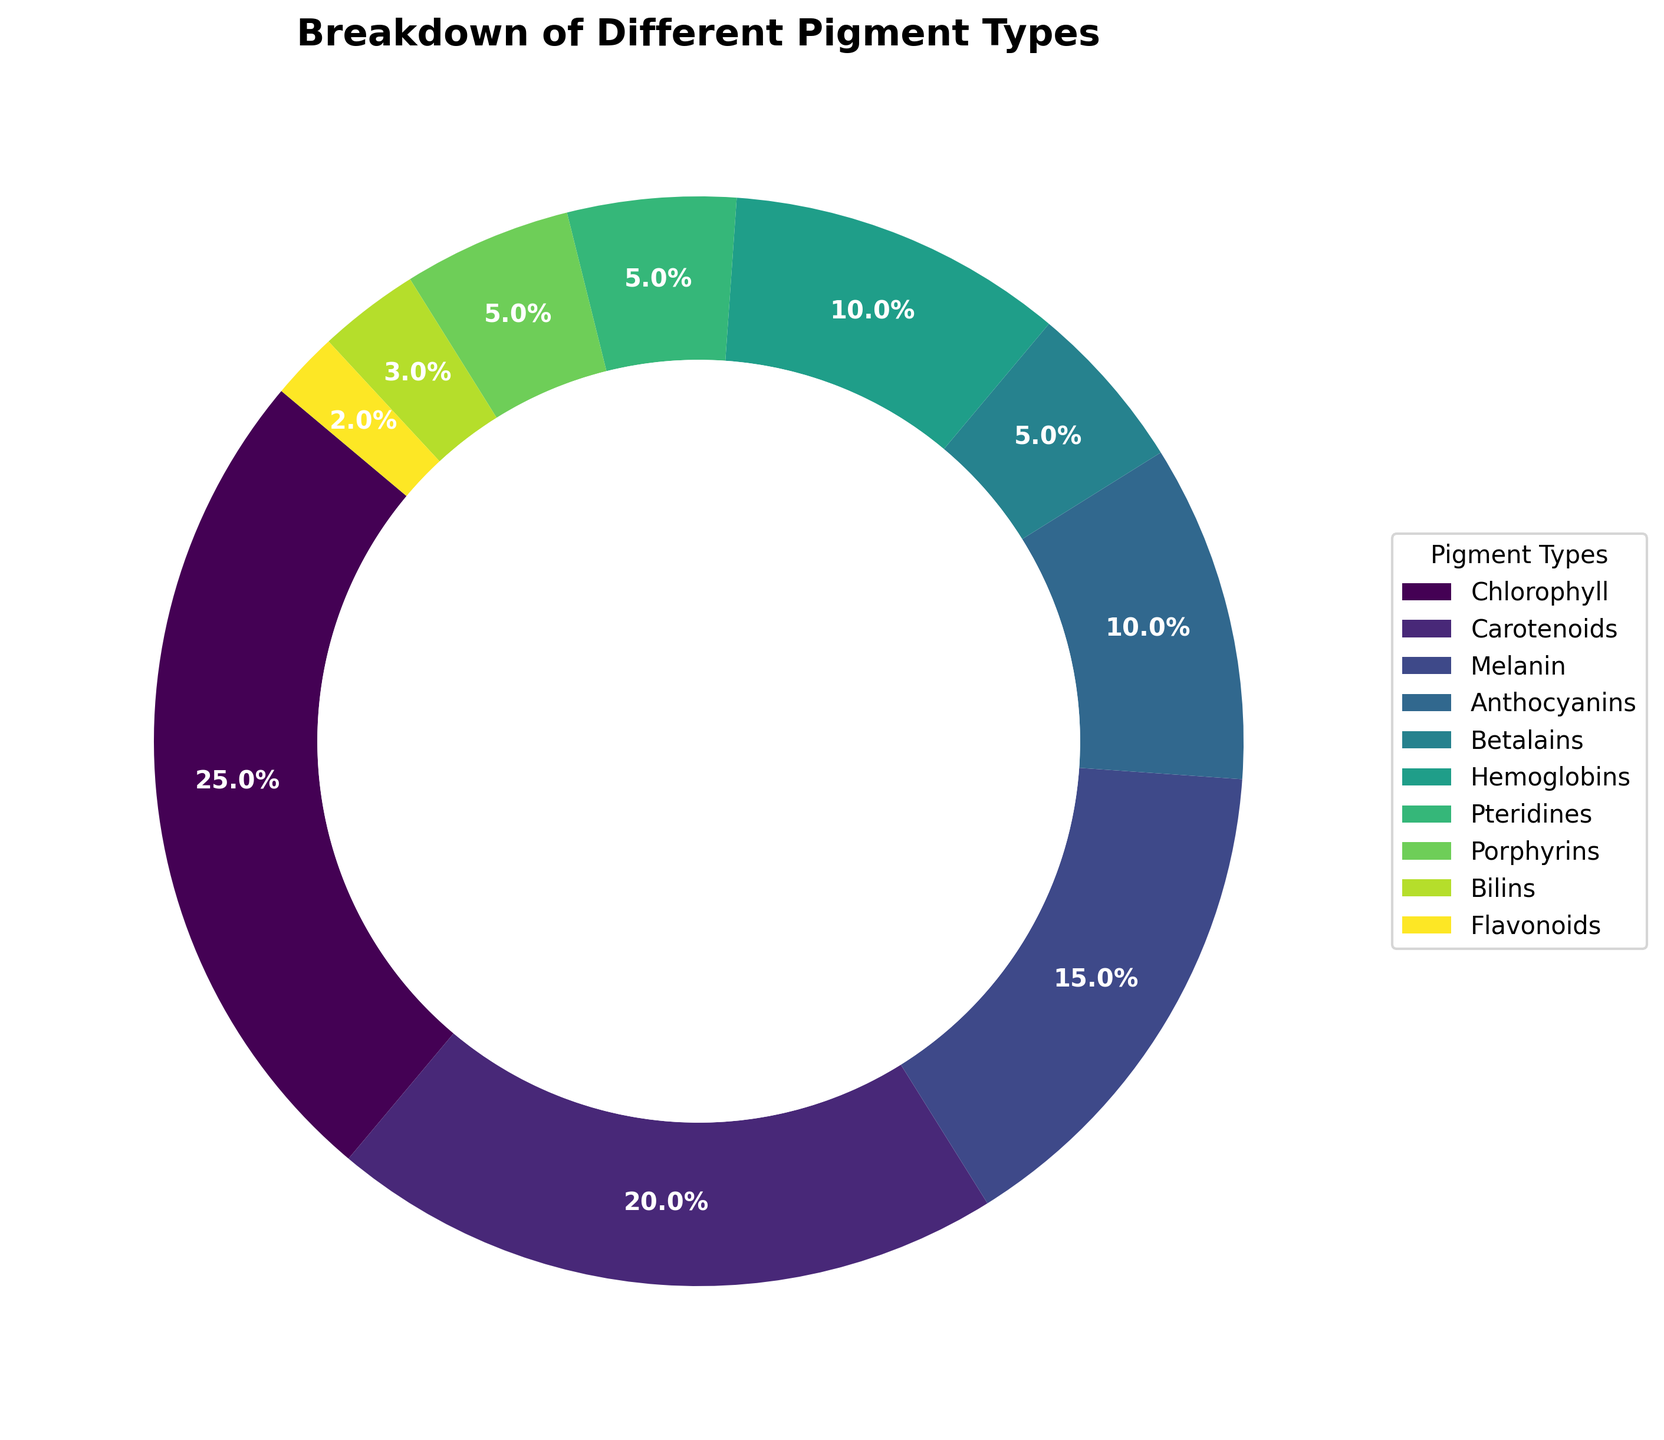Which pigment type is the most abundant in the figure? By referring to the figure, we can see that chlorophyll takes up the largest portion of the pie chart, which is 25%.
Answer: Chlorophyll How much more prevalent is chlorophyll compared to flavonoids? Chlorophyll is 25% while flavonoids are 2%. Calculate the difference: 25% - 2% = 23%.
Answer: 23% What percentage of the pie chart do carotenoids and anthocyanins together represent? Carotenoids make up 20% and anthocyanins 10%. Add these percentages together: 20% + 10% = 30%.
Answer: 30% Which pigment types have an equal representation in the pie chart? By observing the visual segments, pteridines, porphyrins, and betalains each take up 5% of the pie chart, indicating equal representation.
Answer: Pteridines, Porphyrins, Betalains Are melanin and hemoglobins equally represented? If not, which is more prevalent and by how much? Melanin is 15% while hemoglobins are 10%. Melanin is more prevalent. The difference is 15% - 10% = 5%.
Answer: No, Melanin is more prevalent by 5% What proportion of the pie chart is taken up by pigments found in animals (melanin, hemoglobins, pteridines)? Melanin is 15%, hemoglobins are 10%, and pteridines are 5%. Add these percentages together: 15% + 10% + 5% = 30%.
Answer: 30% If you combine the percentages of bilins and flavonoids, which pigment type has a similar representation to their sum? Bilins are 3% and flavonoids are 2%. Adding them results in: 3% + 2% = 5%, which is the same as the representation of pteridines, porphyrins, and betalains.
Answer: Pteridines, Porphyrins, Betalains 